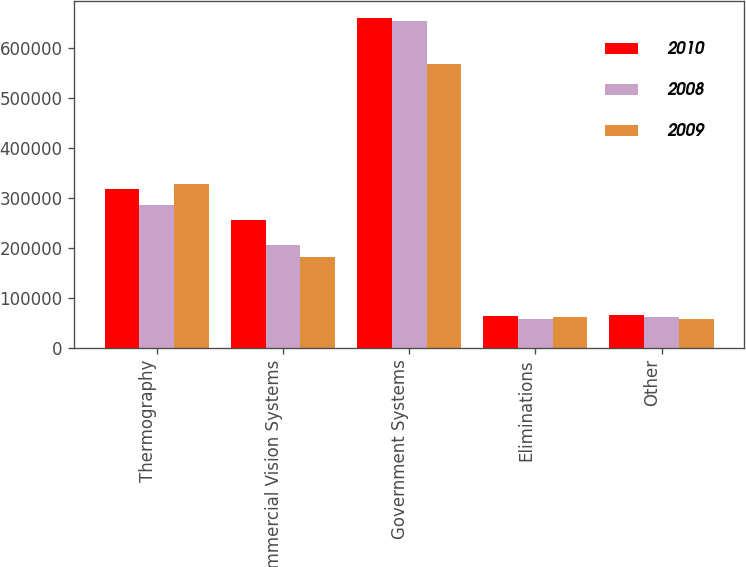Convert chart. <chart><loc_0><loc_0><loc_500><loc_500><stacked_bar_chart><ecel><fcel>Thermography<fcel>Commercial Vision Systems<fcel>Government Systems<fcel>Eliminations<fcel>Other<nl><fcel>2010<fcel>317936<fcel>256102<fcel>661072<fcel>64271<fcel>65408<nl><fcel>2008<fcel>285482<fcel>206323<fcel>655282<fcel>56890<fcel>61293<nl><fcel>2009<fcel>327324<fcel>180622<fcel>569028<fcel>61301<fcel>57276<nl></chart> 